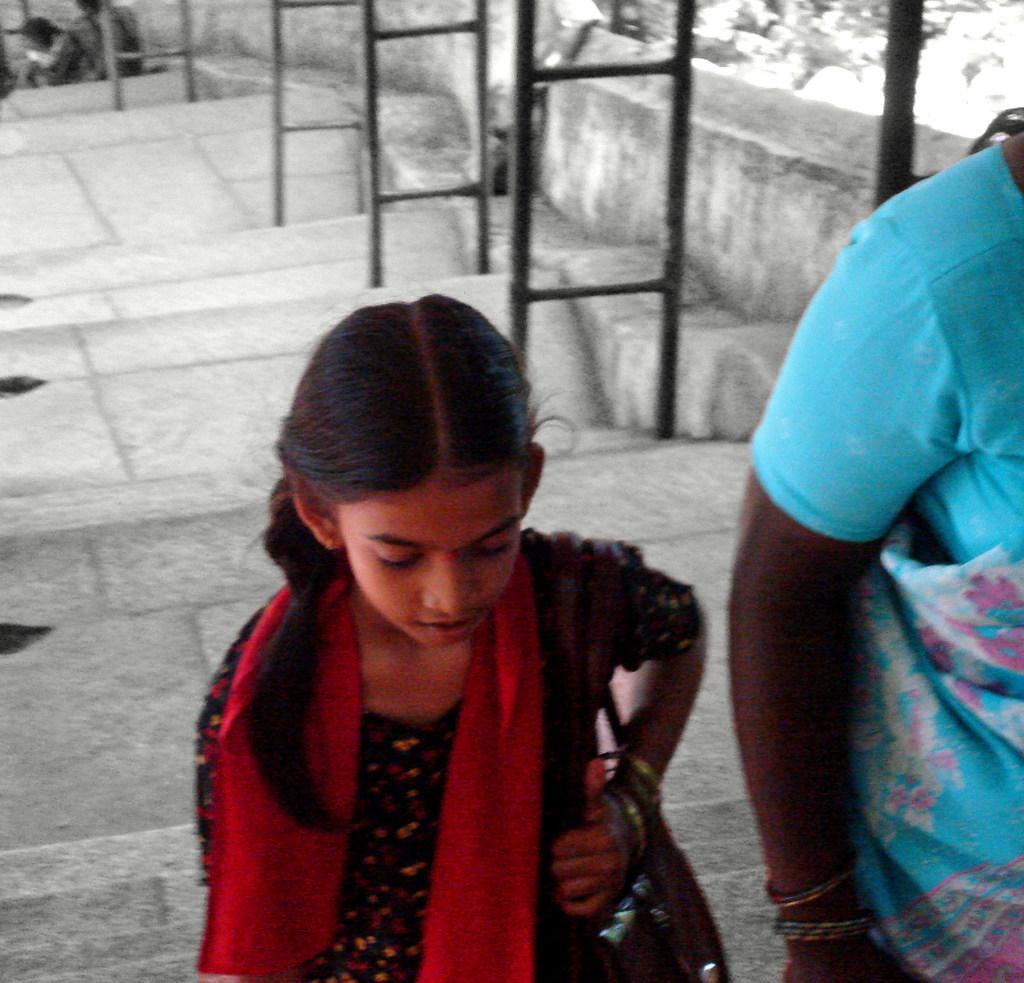Could you give a brief overview of what you see in this image? In the picture we can see a girl walking in the long steps and beside her we can see a woman also is walking and behind them, we can see the steps and beside it we can see a wall and near it we can see iron poles. 